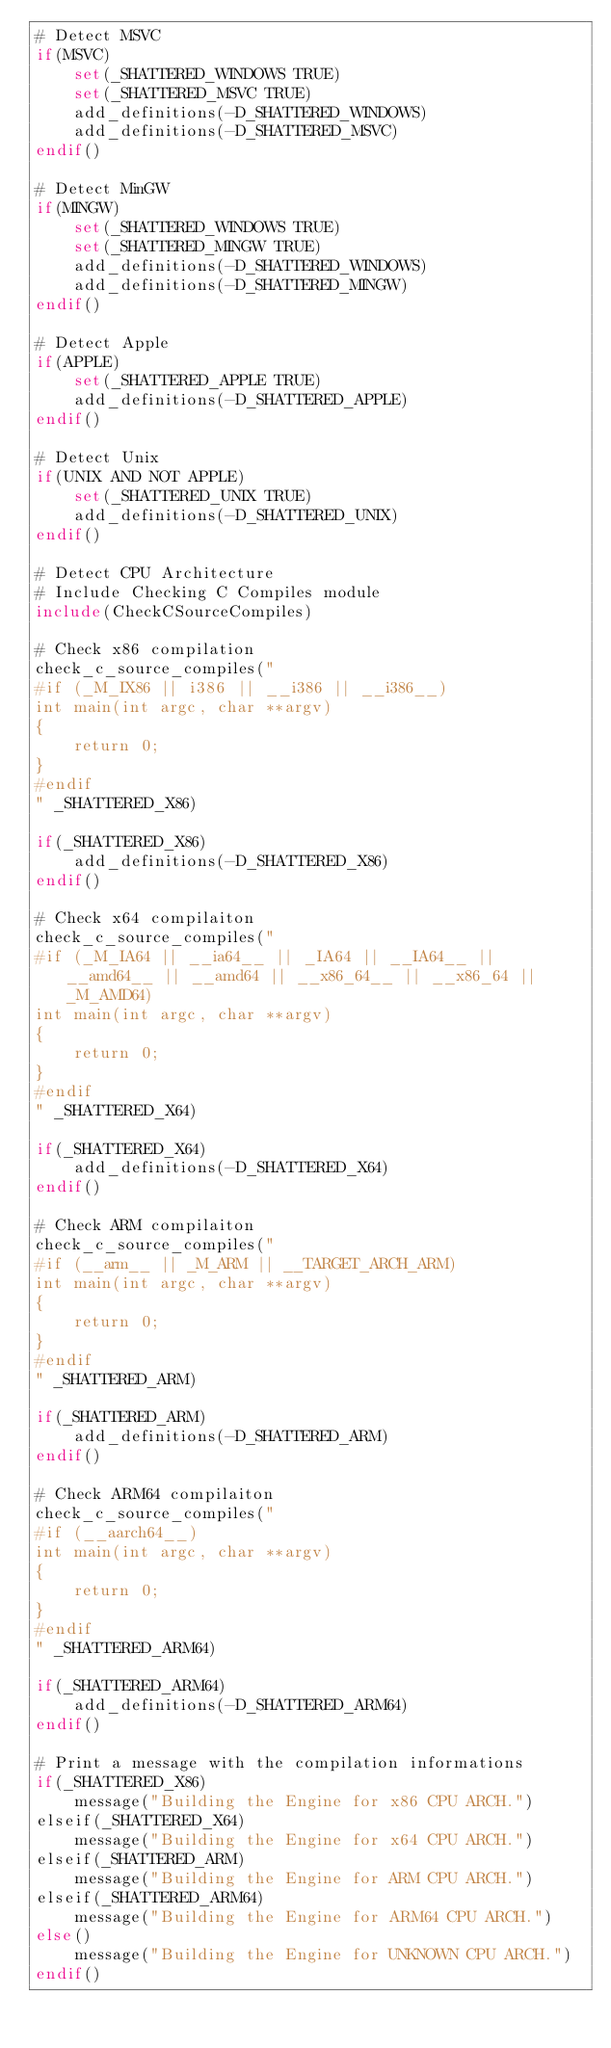Convert code to text. <code><loc_0><loc_0><loc_500><loc_500><_CMake_># Detect MSVC
if(MSVC)
	set(_SHATTERED_WINDOWS TRUE)
	set(_SHATTERED_MSVC TRUE)
	add_definitions(-D_SHATTERED_WINDOWS)
	add_definitions(-D_SHATTERED_MSVC)
endif()

# Detect MinGW
if(MINGW)
	set(_SHATTERED_WINDOWS TRUE)
	set(_SHATTERED_MINGW TRUE)
	add_definitions(-D_SHATTERED_WINDOWS)
	add_definitions(-D_SHATTERED_MINGW)
endif()

# Detect Apple
if(APPLE)
	set(_SHATTERED_APPLE TRUE)
	add_definitions(-D_SHATTERED_APPLE)
endif()

# Detect Unix
if(UNIX AND NOT APPLE)
	set(_SHATTERED_UNIX TRUE)
	add_definitions(-D_SHATTERED_UNIX)
endif()

# Detect CPU Architecture
# Include Checking C Compiles module
include(CheckCSourceCompiles)

# Check x86 compilation
check_c_source_compiles("
#if (_M_IX86 || i386 || __i386 || __i386__)
int main(int argc, char **argv)
{
	return 0;
}
#endif
" _SHATTERED_X86)

if(_SHATTERED_X86)
	add_definitions(-D_SHATTERED_X86)
endif()

# Check x64 compilaiton
check_c_source_compiles("
#if (_M_IA64 || __ia64__ || _IA64 || __IA64__ || __amd64__ || __amd64 || __x86_64__ || __x86_64 || _M_AMD64)
int main(int argc, char **argv)
{
	return 0;
}
#endif
" _SHATTERED_X64)

if(_SHATTERED_X64)
	add_definitions(-D_SHATTERED_X64)
endif()

# Check ARM compilaiton
check_c_source_compiles("
#if (__arm__ || _M_ARM || __TARGET_ARCH_ARM)
int main(int argc, char **argv)
{
	return 0;
}
#endif
" _SHATTERED_ARM)

if(_SHATTERED_ARM)
	add_definitions(-D_SHATTERED_ARM)
endif()

# Check ARM64 compilaiton
check_c_source_compiles("
#if (__aarch64__)
int main(int argc, char **argv)
{
	return 0;
}
#endif
" _SHATTERED_ARM64)

if(_SHATTERED_ARM64)
	add_definitions(-D_SHATTERED_ARM64)
endif()

# Print a message with the compilation informations
if(_SHATTERED_X86)
	message("Building the Engine for x86 CPU ARCH.")
elseif(_SHATTERED_X64)
	message("Building the Engine for x64 CPU ARCH.")
elseif(_SHATTERED_ARM)
	message("Building the Engine for ARM CPU ARCH.")
elseif(_SHATTERED_ARM64)
	message("Building the Engine for ARM64 CPU ARCH.")
else()
	message("Building the Engine for UNKNOWN CPU ARCH.")
endif()
</code> 